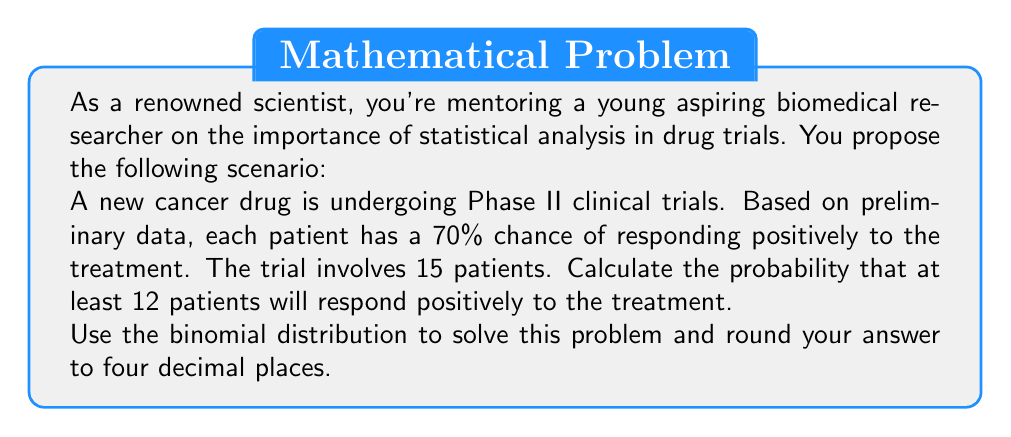Teach me how to tackle this problem. To solve this problem, we'll use the binomial distribution formula and the concept of cumulative probability.

1) The binomial distribution is given by:

   $$P(X = k) = \binom{n}{k} p^k (1-p)^{n-k}$$

   Where:
   $n$ = number of trials (15 patients)
   $k$ = number of successes
   $p$ = probability of success for each trial (70% or 0.7)

2) We need to find $P(X \geq 12)$, which is equivalent to:

   $P(X = 12) + P(X = 13) + P(X = 14) + P(X = 15)$

3) Let's calculate each probability:

   For $k = 12$:
   $$P(X = 12) = \binom{15}{12} (0.7)^{12} (0.3)^3 = 0.1852$$

   For $k = 13$:
   $$P(X = 13) = \binom{15}{13} (0.7)^{13} (0.3)^2 = 0.1004$$

   For $k = 14$:
   $$P(X = 14) = \binom{15}{14} (0.7)^{14} (0.3)^1 = 0.0265$$

   For $k = 15$:
   $$P(X = 15) = \binom{15}{15} (0.7)^{15} (0.3)^0 = 0.0025$$

4) Sum these probabilities:

   $P(X \geq 12) = 0.1852 + 0.1004 + 0.0265 + 0.0025 = 0.3146$

5) Rounding to four decimal places:

   $P(X \geq 12) = 0.3146$
Answer: 0.3146 